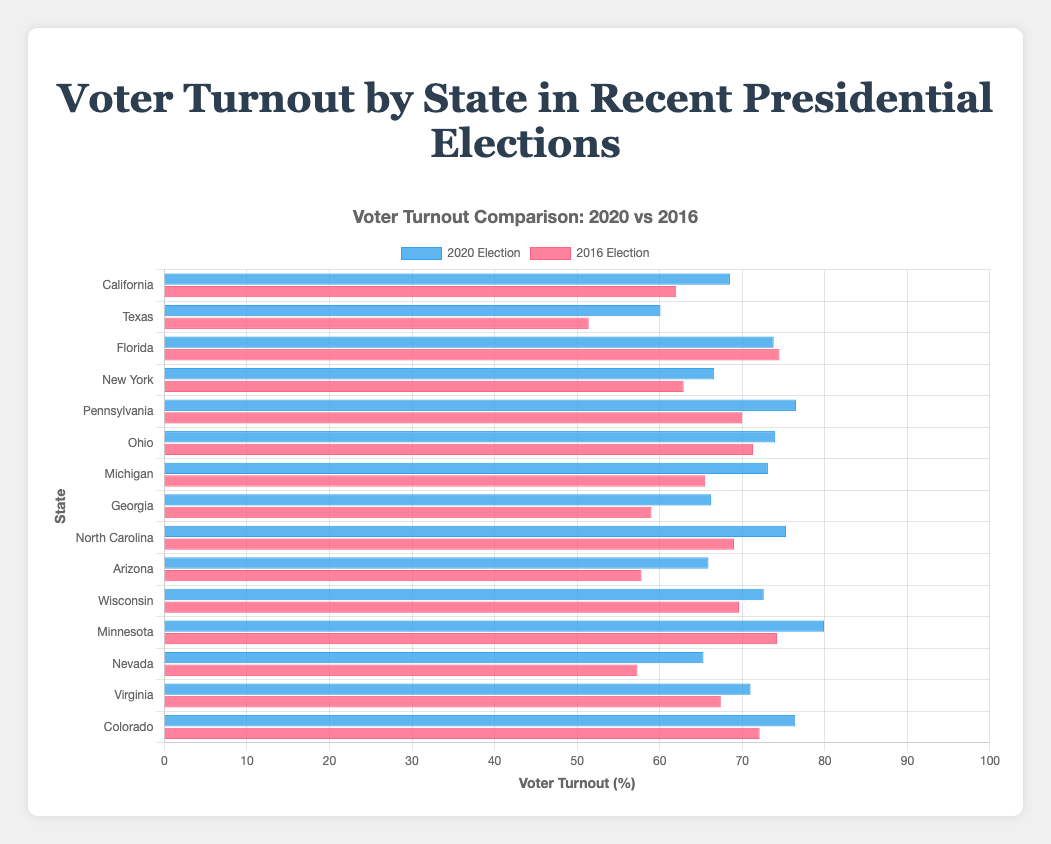Which state had the highest voter turnout in 2020? Looking at the longest bar in the dataset for 2020, Minnesota had the highest voter turnout.
Answer: Minnesota Which state had a decrease in voter turnout from 2016 to 2020? Identifying the states where the bar for 2020 is shorter than the 2016 bar reveals that Florida had a decrease in voter turnout.
Answer: Florida What is the average voter turnout for California across both election years? Adding the turnout for California for both years (68.5 + 62.0) and then dividing by 2 gives the average. (68.5 + 62.0)/2 = 65.25
Answer: 65.25 Which state had the largest increase in voter turnout from 2016 to 2020? Subtracting the 2016 turnout from the 2020 turnout for each state, the largest difference is in Arizona (65.9 - 57.8 = 8.1).
Answer: Arizona How does Pennsylvania's voter turnout in 2020 compare to Ohio's in 2016? Comparing the bars for Pennsylvania in 2020 (76.5) and Ohio in 2016 (71.3), Pennsylvania in 2020 had higher voter turnout.
Answer: Pennsylvania 2020's turnout is higher If you combine the voter turnouts for both years, which state has the highest total voter turnout? Adding up the voter turnout numbers for both years for all states, Minnesota has the highest combined turnout (79.9 + 74.2 = 154.1).
Answer: Minnesota Which state had voter turnouts that were both below 60% and above 60% in 2016 and 2020, respectively? Checking the states whose bars cross the 60% mark between years, Texas (51.4 in 2016, 60.1 in 2020) and Georgia (59.0 in 2016, 66.2 in 2020) qualify.
Answer: Texas, Georgia What's the average voter turnout in 2020 for states with a turnout above 75% in 2020? Adding the voter turnouts for states above 75% in 2020 (Pennsylvania 76.5, North Carolina 75.3, Colorado 76.4, Minnesota 79.9), then dividing by 4 gives (76.5 + 75.3 + 76.4 + 79.9)/4 = 77.03
Answer: 77.03 